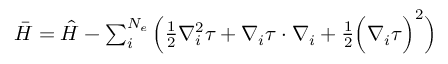<formula> <loc_0><loc_0><loc_500><loc_500>\begin{array} { r } { \bar { H } = \hat { H } - \sum _ { i } ^ { N _ { e } } \left ( \frac { 1 } { 2 } \nabla _ { i } ^ { 2 } \tau + \nabla _ { i } \tau \cdot \nabla _ { i } + \frac { 1 } { 2 } \left ( \nabla _ { i } \tau \right ) ^ { 2 } \right ) } \end{array}</formula> 